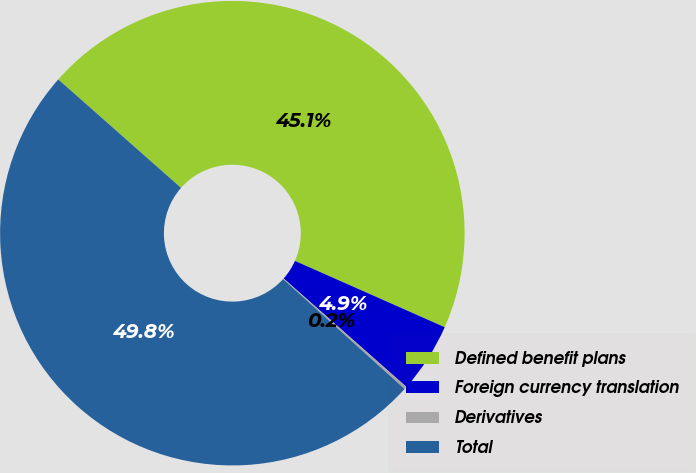Convert chart to OTSL. <chart><loc_0><loc_0><loc_500><loc_500><pie_chart><fcel>Defined benefit plans<fcel>Foreign currency translation<fcel>Derivatives<fcel>Total<nl><fcel>45.12%<fcel>4.88%<fcel>0.19%<fcel>49.81%<nl></chart> 